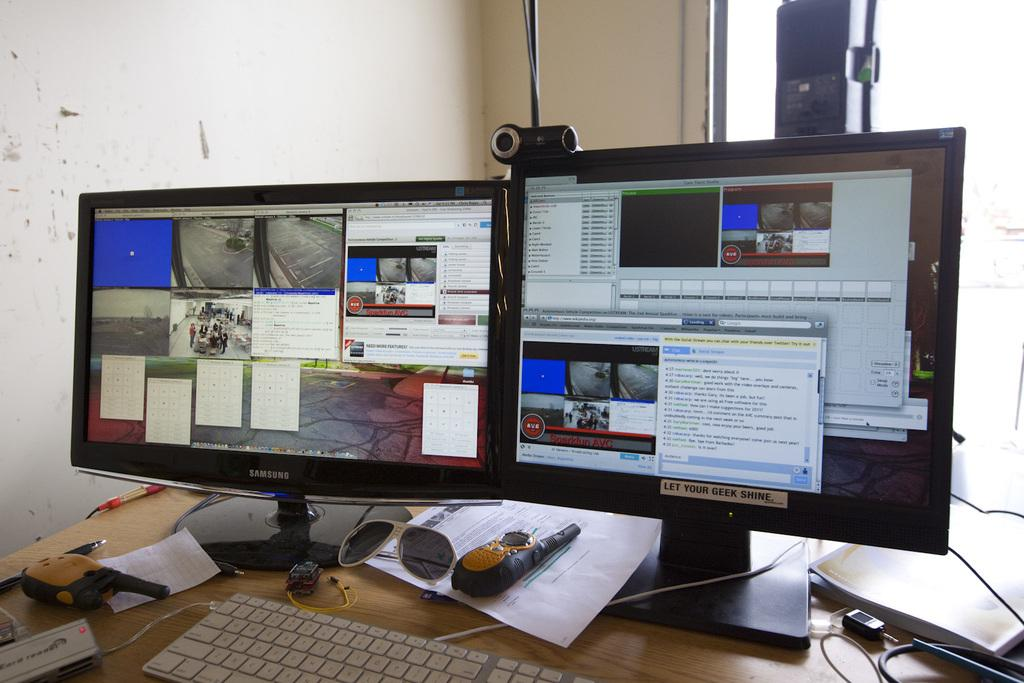What type of electronic devices can be seen in the image? There are monitors and keyboards in the image. What type of stationery items are present in the image? There are papers in the image. What type of cables are visible in the image? There are wires in the image. What type of objects are on the table in the image? There are objects on the table in the image, including monitors, keyboards, papers, and wires. What type of background can be seen in the image? There is a wall visible in the image. What type of jam is being spread on the hydrant in the image? There is no jam or hydrant present in the image. What time of day is depicted in the image? The time of day cannot be determined from the image, as there are no clues about the lighting or shadows. 